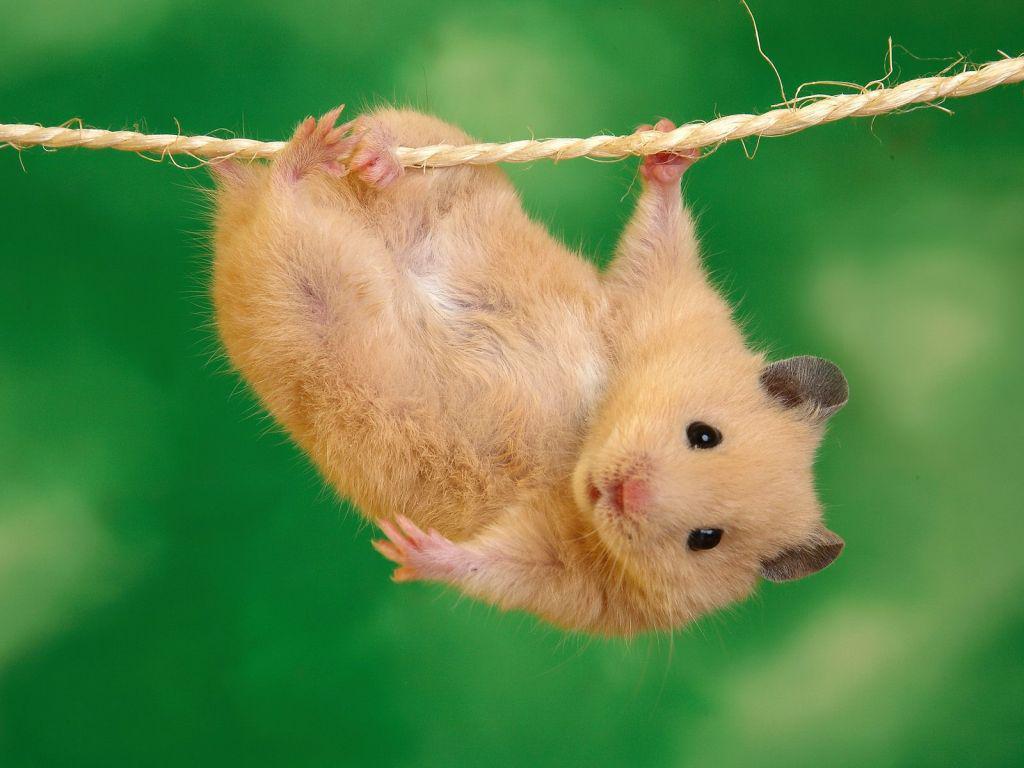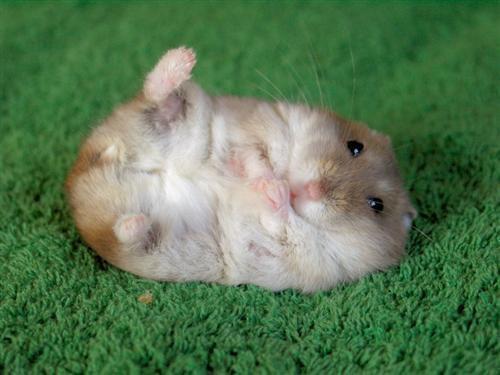The first image is the image on the left, the second image is the image on the right. Analyze the images presented: Is the assertion "A hamster is holding a string." valid? Answer yes or no. Yes. 